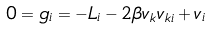Convert formula to latex. <formula><loc_0><loc_0><loc_500><loc_500>0 = g _ { i } = - L _ { i } - 2 \beta v _ { k } v _ { k i } + v _ { i }</formula> 